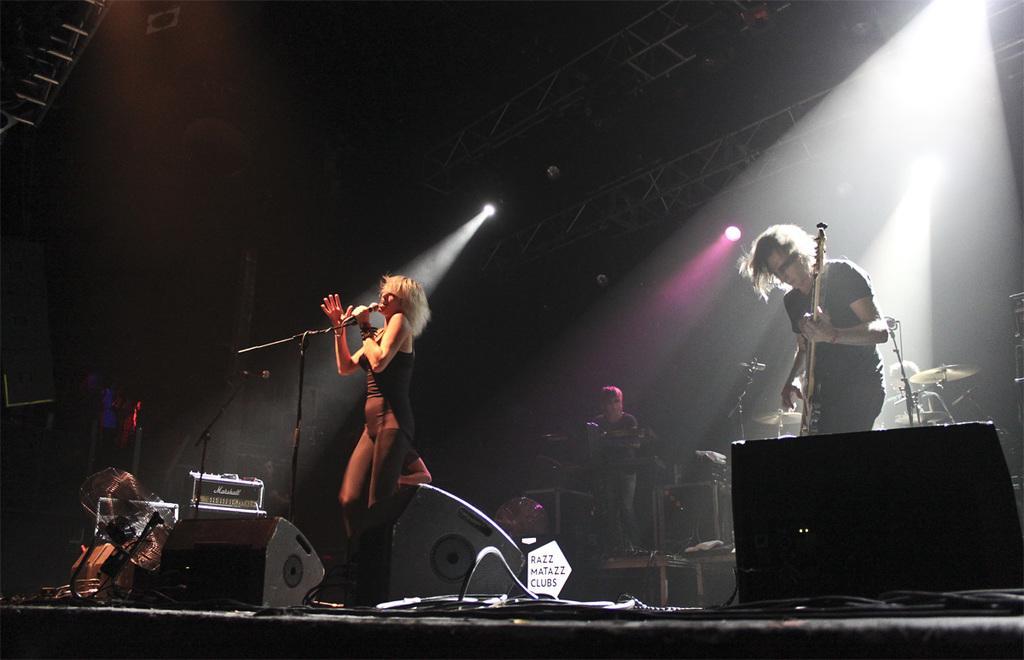How would you summarize this image in a sentence or two? In this picture I can see a woman singing with the help of a microphone on the dais and I can see a man playing a guitar and another human playing a piano and another person playing drums in the back and I can see lights and speakers on the dais and I can see dark background and a small board with some text at the bottom. 